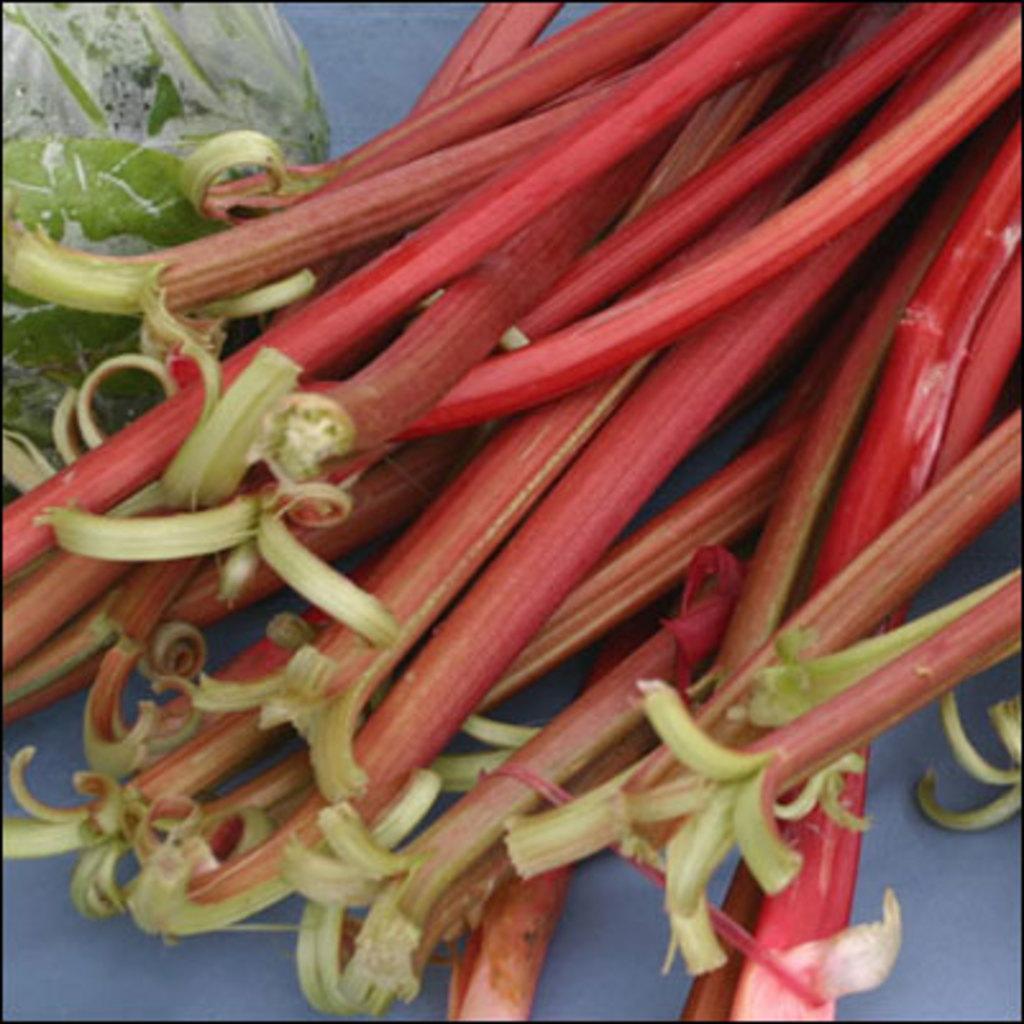Please provide a concise description of this image. In this image we can see some garden rhubarbs on a white colored surface. 